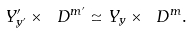<formula> <loc_0><loc_0><loc_500><loc_500>Y ^ { \prime } _ { y ^ { \prime } } \times \ D ^ { m ^ { \prime } } \simeq Y _ { y } \times \ D ^ { m } .</formula> 